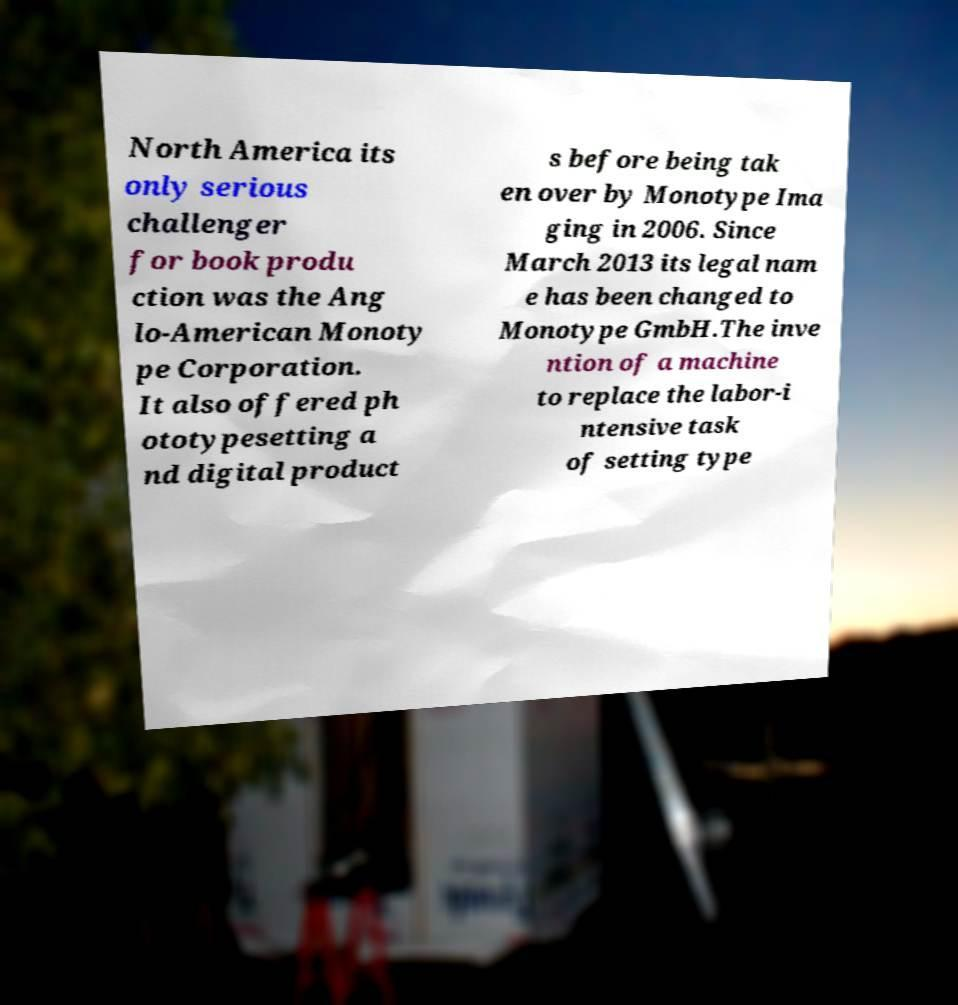Could you assist in decoding the text presented in this image and type it out clearly? North America its only serious challenger for book produ ction was the Ang lo-American Monoty pe Corporation. It also offered ph ototypesetting a nd digital product s before being tak en over by Monotype Ima ging in 2006. Since March 2013 its legal nam e has been changed to Monotype GmbH.The inve ntion of a machine to replace the labor-i ntensive task of setting type 